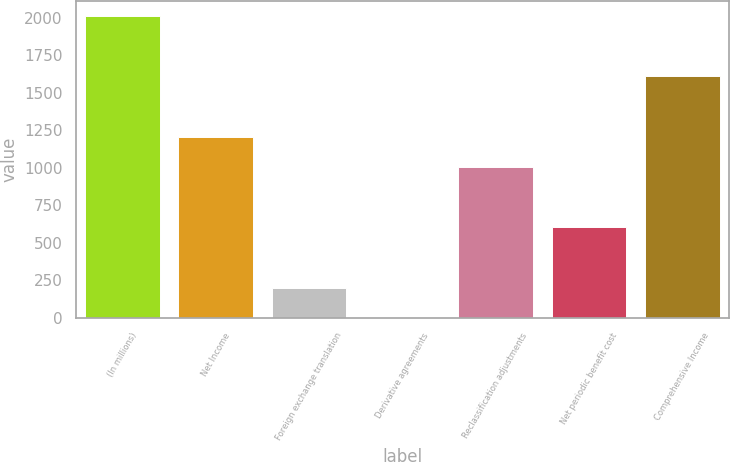Convert chart. <chart><loc_0><loc_0><loc_500><loc_500><bar_chart><fcel>(In millions)<fcel>Net Income<fcel>Foreign exchange translation<fcel>Derivative agreements<fcel>Reclassification adjustments<fcel>Net periodic benefit cost<fcel>Comprehensive Income<nl><fcel>2010<fcel>1206.32<fcel>201.72<fcel>0.8<fcel>1005.4<fcel>603.56<fcel>1608.16<nl></chart> 